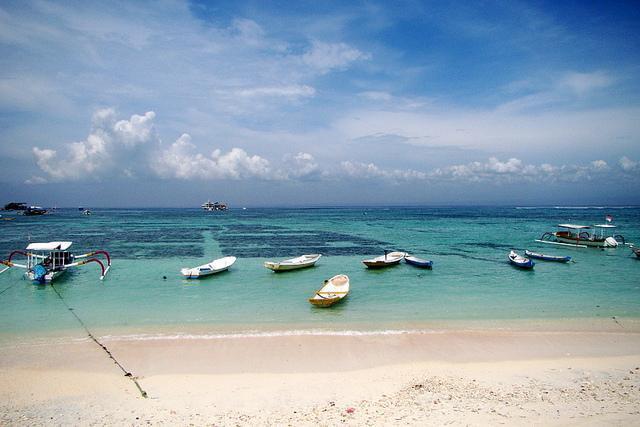How many people are holding a bag?
Give a very brief answer. 0. 